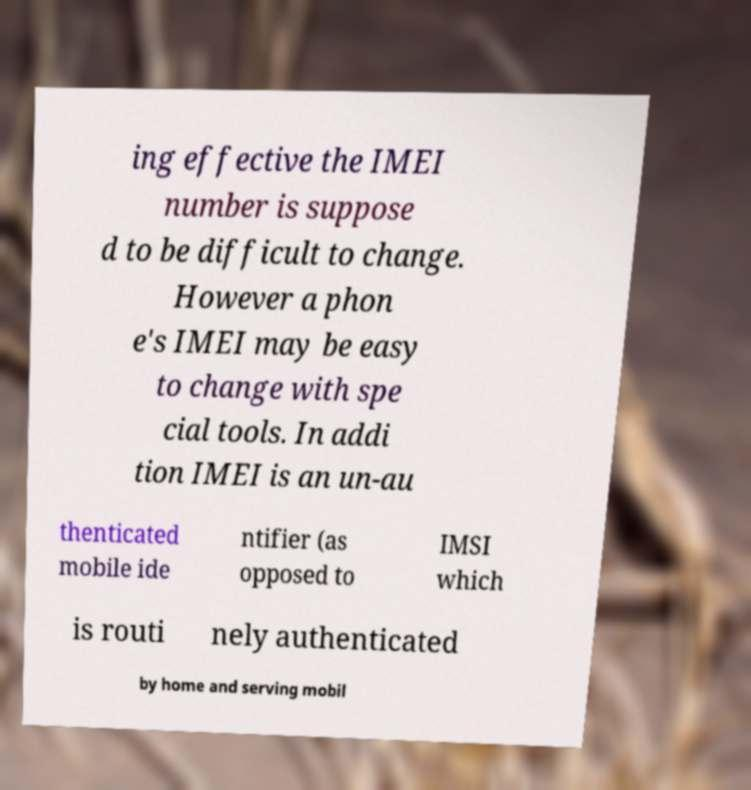Could you assist in decoding the text presented in this image and type it out clearly? ing effective the IMEI number is suppose d to be difficult to change. However a phon e's IMEI may be easy to change with spe cial tools. In addi tion IMEI is an un-au thenticated mobile ide ntifier (as opposed to IMSI which is routi nely authenticated by home and serving mobil 